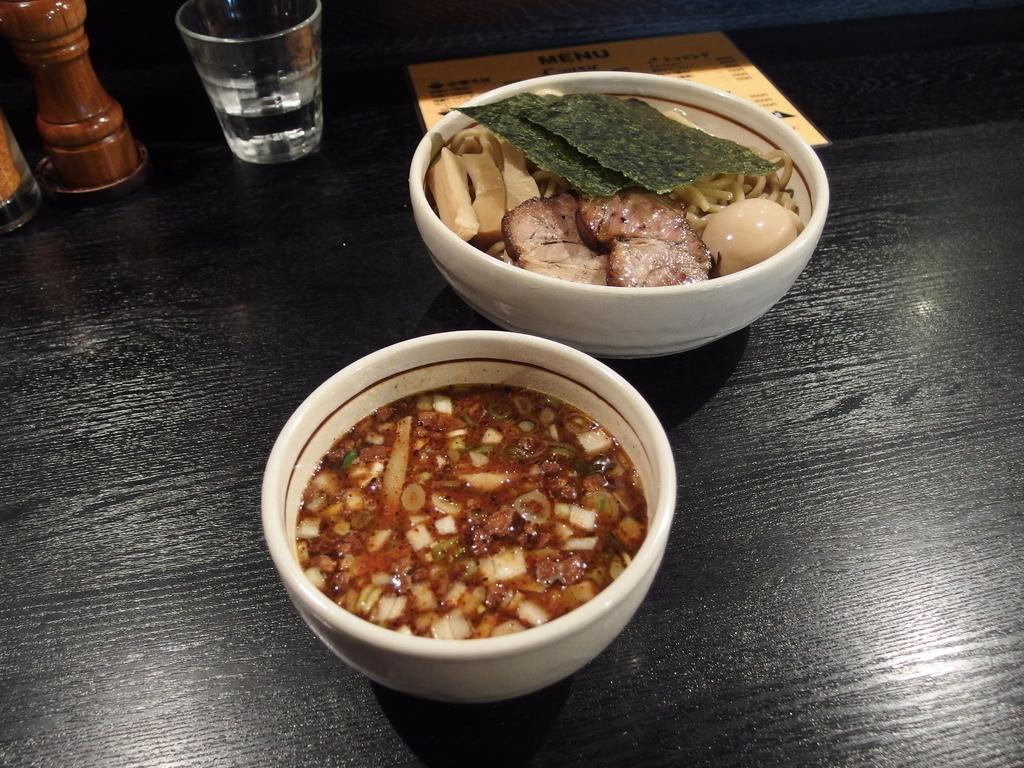What is in the serving bowls that can be seen in the image? There are serving bowls with food in the image. What might be used to order food in the image? There is a menu card in the image. What condiments are visible in the image? Salt and pepper sprinklers are visible in the image. What type of container is present for holding a beverage? There is a glass tumbler in the image. How does the cannon fire in the image? There is no cannon present in the image. What color is the paint used to decorate the food in the image? There is no paint or decoration on the food in the image; it is simply served in bowls. 